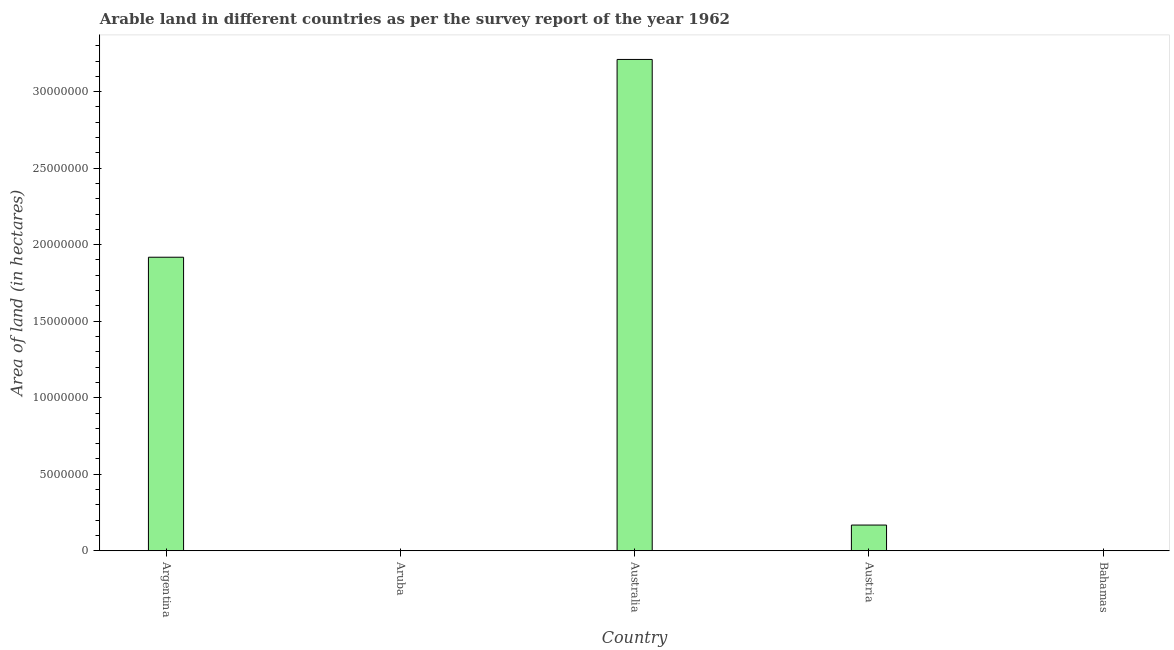Does the graph contain grids?
Offer a terse response. No. What is the title of the graph?
Make the answer very short. Arable land in different countries as per the survey report of the year 1962. What is the label or title of the X-axis?
Your answer should be compact. Country. What is the label or title of the Y-axis?
Your answer should be very brief. Area of land (in hectares). What is the area of land in Australia?
Provide a short and direct response. 3.21e+07. Across all countries, what is the maximum area of land?
Offer a terse response. 3.21e+07. Across all countries, what is the minimum area of land?
Provide a succinct answer. 2000. In which country was the area of land maximum?
Your answer should be compact. Australia. In which country was the area of land minimum?
Keep it short and to the point. Aruba. What is the sum of the area of land?
Ensure brevity in your answer.  5.30e+07. What is the difference between the area of land in Aruba and Austria?
Your response must be concise. -1.68e+06. What is the average area of land per country?
Provide a short and direct response. 1.06e+07. What is the median area of land?
Your answer should be compact. 1.68e+06. In how many countries, is the area of land greater than 19000000 hectares?
Your answer should be compact. 2. What is the ratio of the area of land in Australia to that in Bahamas?
Your response must be concise. 4586.14. Is the area of land in Aruba less than that in Bahamas?
Keep it short and to the point. Yes. What is the difference between the highest and the second highest area of land?
Provide a succinct answer. 1.29e+07. What is the difference between the highest and the lowest area of land?
Provide a short and direct response. 3.21e+07. In how many countries, is the area of land greater than the average area of land taken over all countries?
Your answer should be compact. 2. Are the values on the major ticks of Y-axis written in scientific E-notation?
Offer a terse response. No. What is the Area of land (in hectares) in Argentina?
Keep it short and to the point. 1.92e+07. What is the Area of land (in hectares) in Aruba?
Make the answer very short. 2000. What is the Area of land (in hectares) of Australia?
Offer a terse response. 3.21e+07. What is the Area of land (in hectares) of Austria?
Make the answer very short. 1.68e+06. What is the Area of land (in hectares) in Bahamas?
Your answer should be compact. 7000. What is the difference between the Area of land (in hectares) in Argentina and Aruba?
Your response must be concise. 1.92e+07. What is the difference between the Area of land (in hectares) in Argentina and Australia?
Your answer should be compact. -1.29e+07. What is the difference between the Area of land (in hectares) in Argentina and Austria?
Give a very brief answer. 1.75e+07. What is the difference between the Area of land (in hectares) in Argentina and Bahamas?
Make the answer very short. 1.92e+07. What is the difference between the Area of land (in hectares) in Aruba and Australia?
Provide a short and direct response. -3.21e+07. What is the difference between the Area of land (in hectares) in Aruba and Austria?
Offer a terse response. -1.68e+06. What is the difference between the Area of land (in hectares) in Aruba and Bahamas?
Give a very brief answer. -5000. What is the difference between the Area of land (in hectares) in Australia and Austria?
Provide a succinct answer. 3.04e+07. What is the difference between the Area of land (in hectares) in Australia and Bahamas?
Your answer should be very brief. 3.21e+07. What is the difference between the Area of land (in hectares) in Austria and Bahamas?
Provide a succinct answer. 1.67e+06. What is the ratio of the Area of land (in hectares) in Argentina to that in Aruba?
Provide a succinct answer. 9590. What is the ratio of the Area of land (in hectares) in Argentina to that in Australia?
Ensure brevity in your answer.  0.6. What is the ratio of the Area of land (in hectares) in Argentina to that in Austria?
Your answer should be compact. 11.41. What is the ratio of the Area of land (in hectares) in Argentina to that in Bahamas?
Ensure brevity in your answer.  2740. What is the ratio of the Area of land (in hectares) in Aruba to that in Austria?
Your response must be concise. 0. What is the ratio of the Area of land (in hectares) in Aruba to that in Bahamas?
Provide a succinct answer. 0.29. What is the ratio of the Area of land (in hectares) in Australia to that in Austria?
Make the answer very short. 19.1. What is the ratio of the Area of land (in hectares) in Australia to that in Bahamas?
Offer a terse response. 4586.14. What is the ratio of the Area of land (in hectares) in Austria to that in Bahamas?
Make the answer very short. 240.14. 